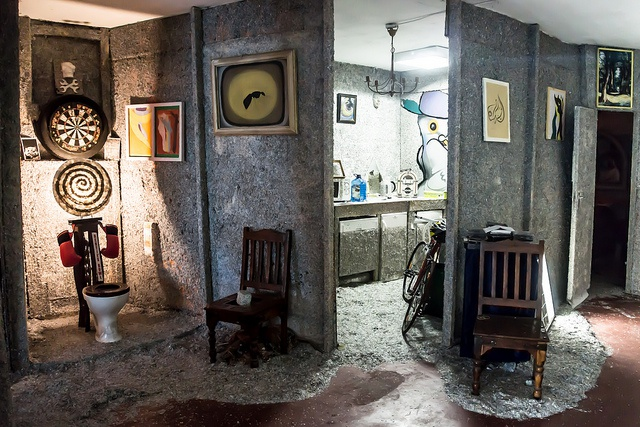Describe the objects in this image and their specific colors. I can see chair in black, gray, and maroon tones, chair in black, gray, and purple tones, bicycle in black, gray, darkgray, and lightgray tones, toilet in black and gray tones, and bottle in black, lightblue, lightgray, darkgray, and gray tones in this image. 